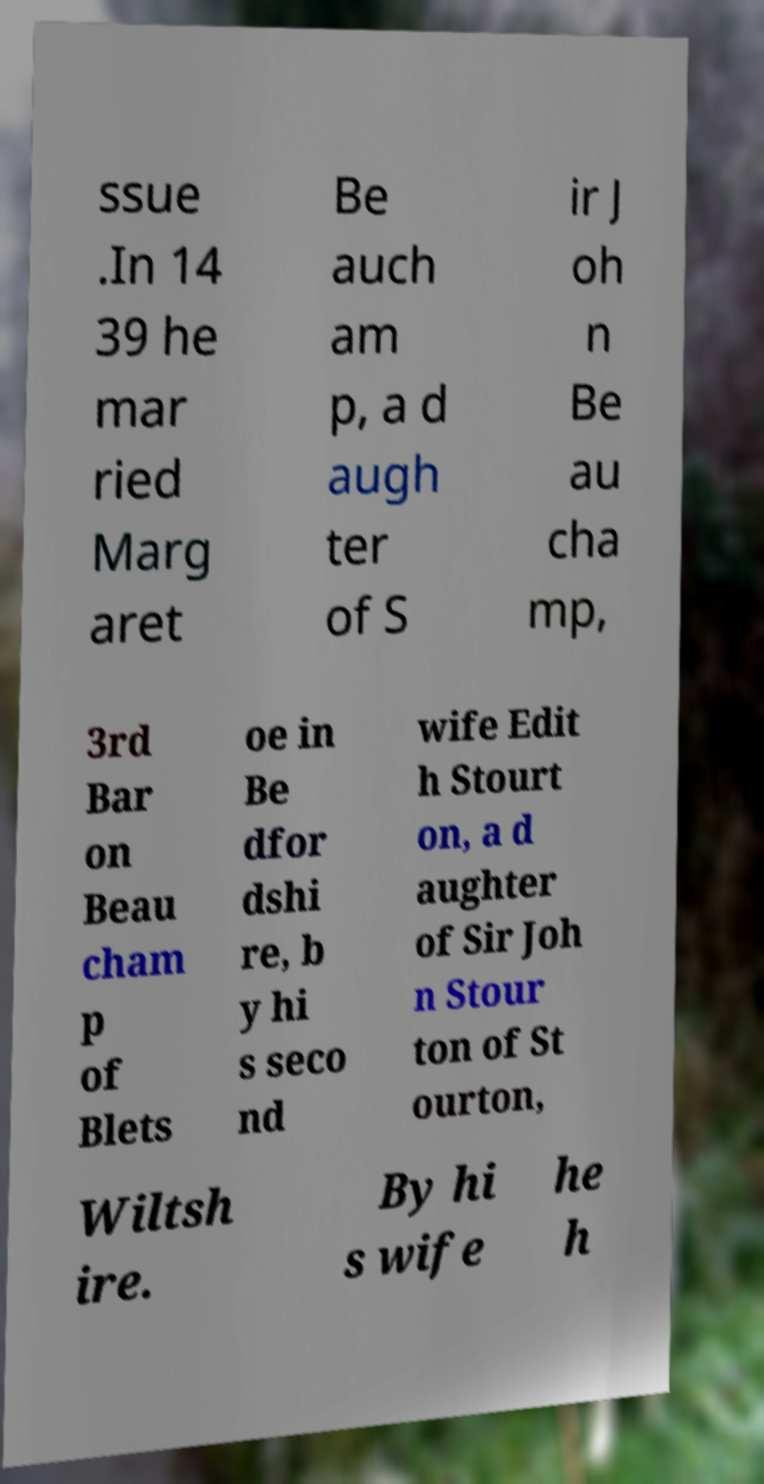What messages or text are displayed in this image? I need them in a readable, typed format. ssue .In 14 39 he mar ried Marg aret Be auch am p, a d augh ter of S ir J oh n Be au cha mp, 3rd Bar on Beau cham p of Blets oe in Be dfor dshi re, b y hi s seco nd wife Edit h Stourt on, a d aughter of Sir Joh n Stour ton of St ourton, Wiltsh ire. By hi s wife he h 